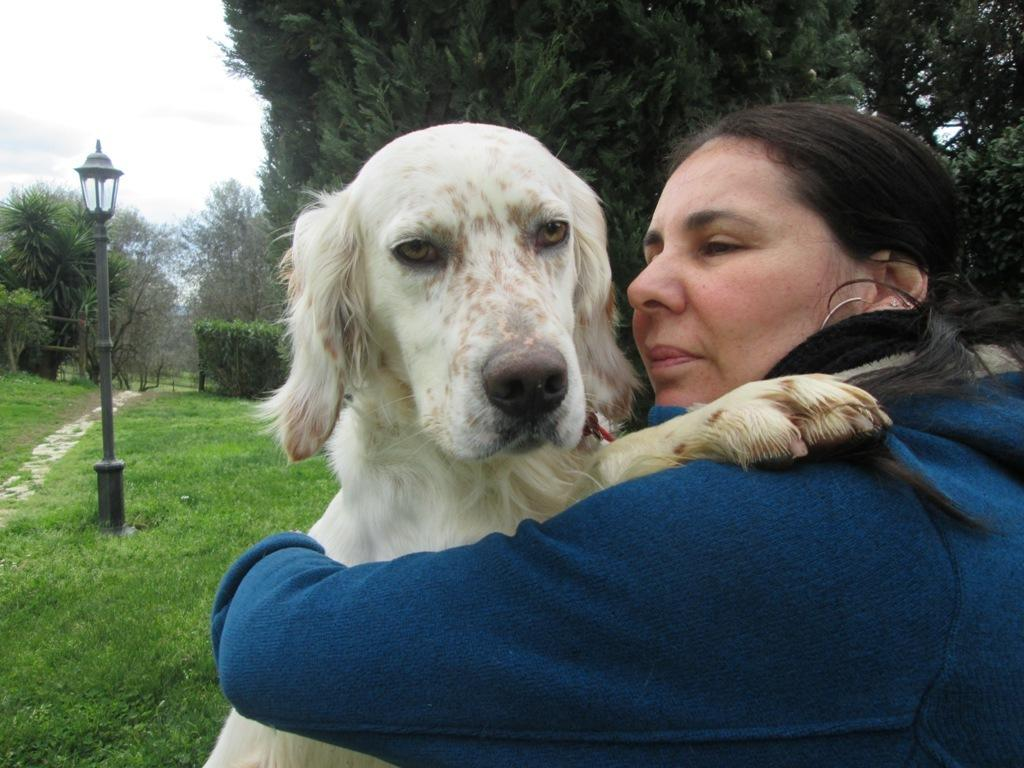Who is the main subject in the image? There is a lady in the image. What is the lady wearing? The lady is wearing a blue dress. What is the lady holding in the image? The lady is holding a dog. What can be seen in the background of the image? There are trees in the background of the image. What type of flooring is visible in the image? There is a grass lawn on the floor. What other structures can be seen in the image? There is the image? Can you see the lady's uncle kissing her in the image? There is no uncle or kissing depicted in the image. 